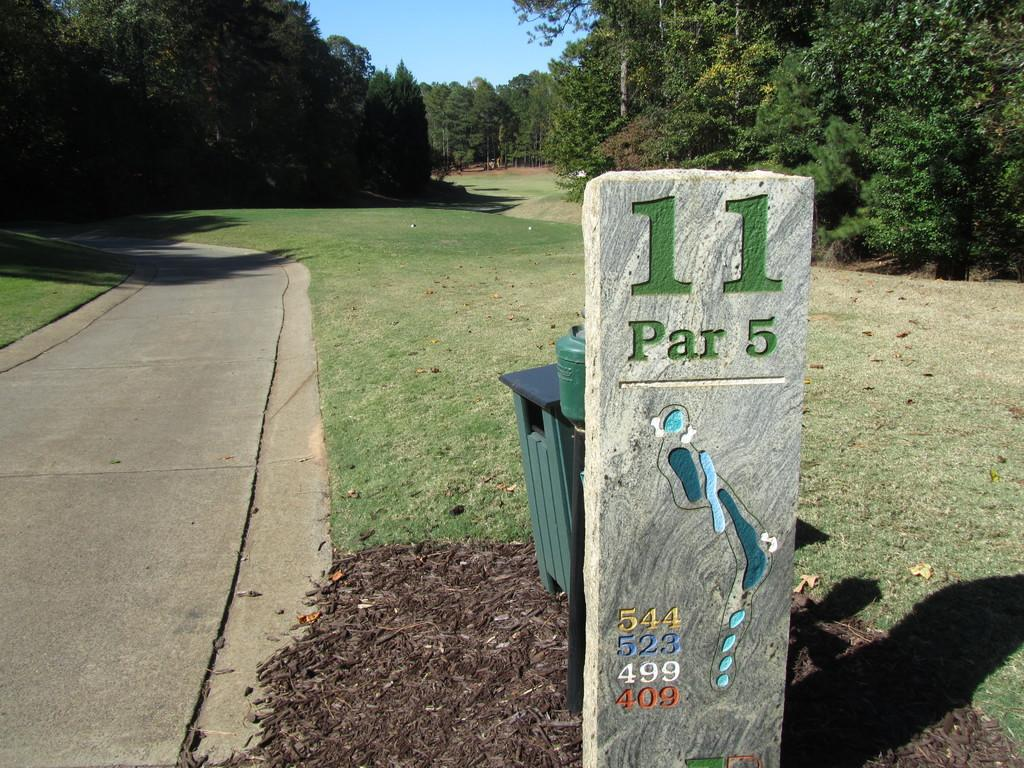<image>
Present a compact description of the photo's key features. the number 11 that is on a little pole 